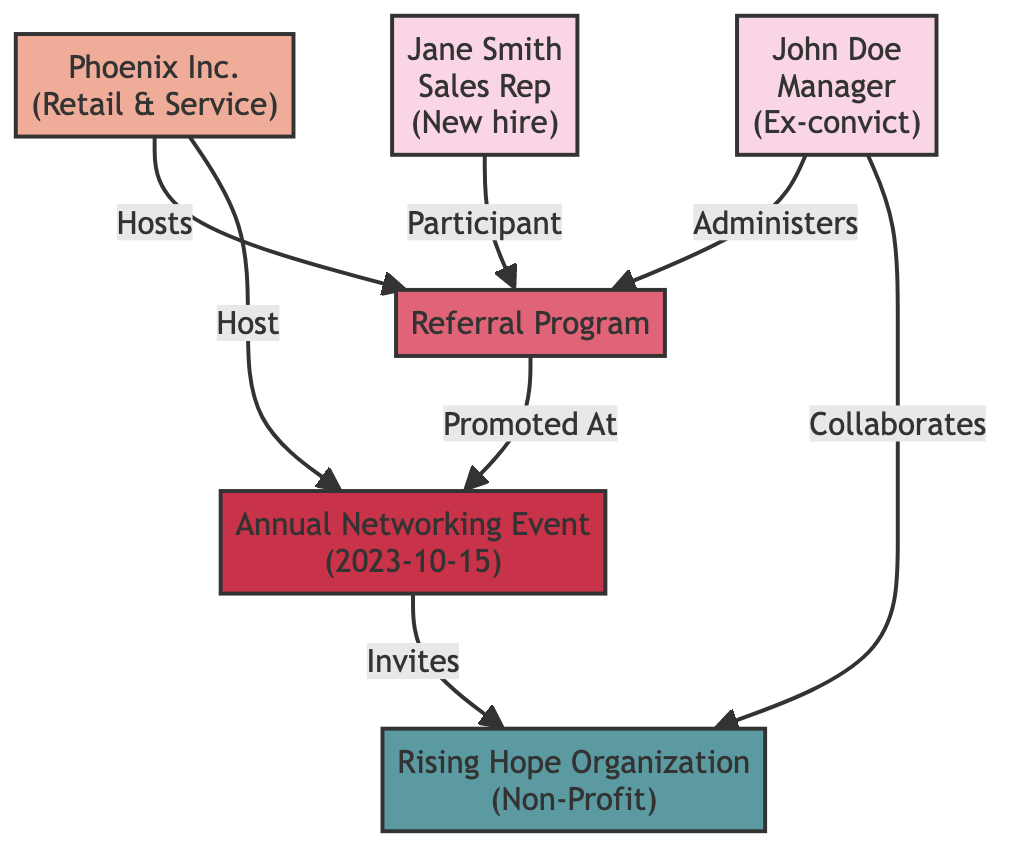What role does John Doe have? The diagram indicates that John Doe is labeled as "Manager," which is specified in his node.
Answer: Manager How many employees are involved in the referral program? There are two employees depicted in the diagram: John Doe (administers) and Jane Smith (participant), both connected to the referral program node.
Answer: 2 What type of organization is Rising Hope? The diagram specifies that Rising Hope Organization is a "Non-Profit" as noted in the node connected to the network event.
Answer: Non-Profit Who administers the referral program? According to the diagram, the relationship from John Doe to the referral program shows that he "Administers" it.
Answer: John Doe How is the Annual Networking Event related to the referral program? The referral program is connected to the network event with the relationship labeled "Promoted At," indicating that the referral program is featured during the annual event.
Answer: Promoted At Which entity hosts the referral program? The connection from Phoenix Inc. to the referral program indicates that Phoenix Inc. "Hosts" this program.
Answer: Phoenix Inc How does John Doe interact with the Rising Hope Organization? The diagram shows that there is a direct relationship labeled "Collaborates" between John Doe and Rising Hope Organization, indicating a collaborative effort.
Answer: Collaborates What event is scheduled for October 15, 2023? The node for the event specifies "Annual Networking Event" with the date mentioned, making this the noted scheduled event.
Answer: Annual Networking Event 